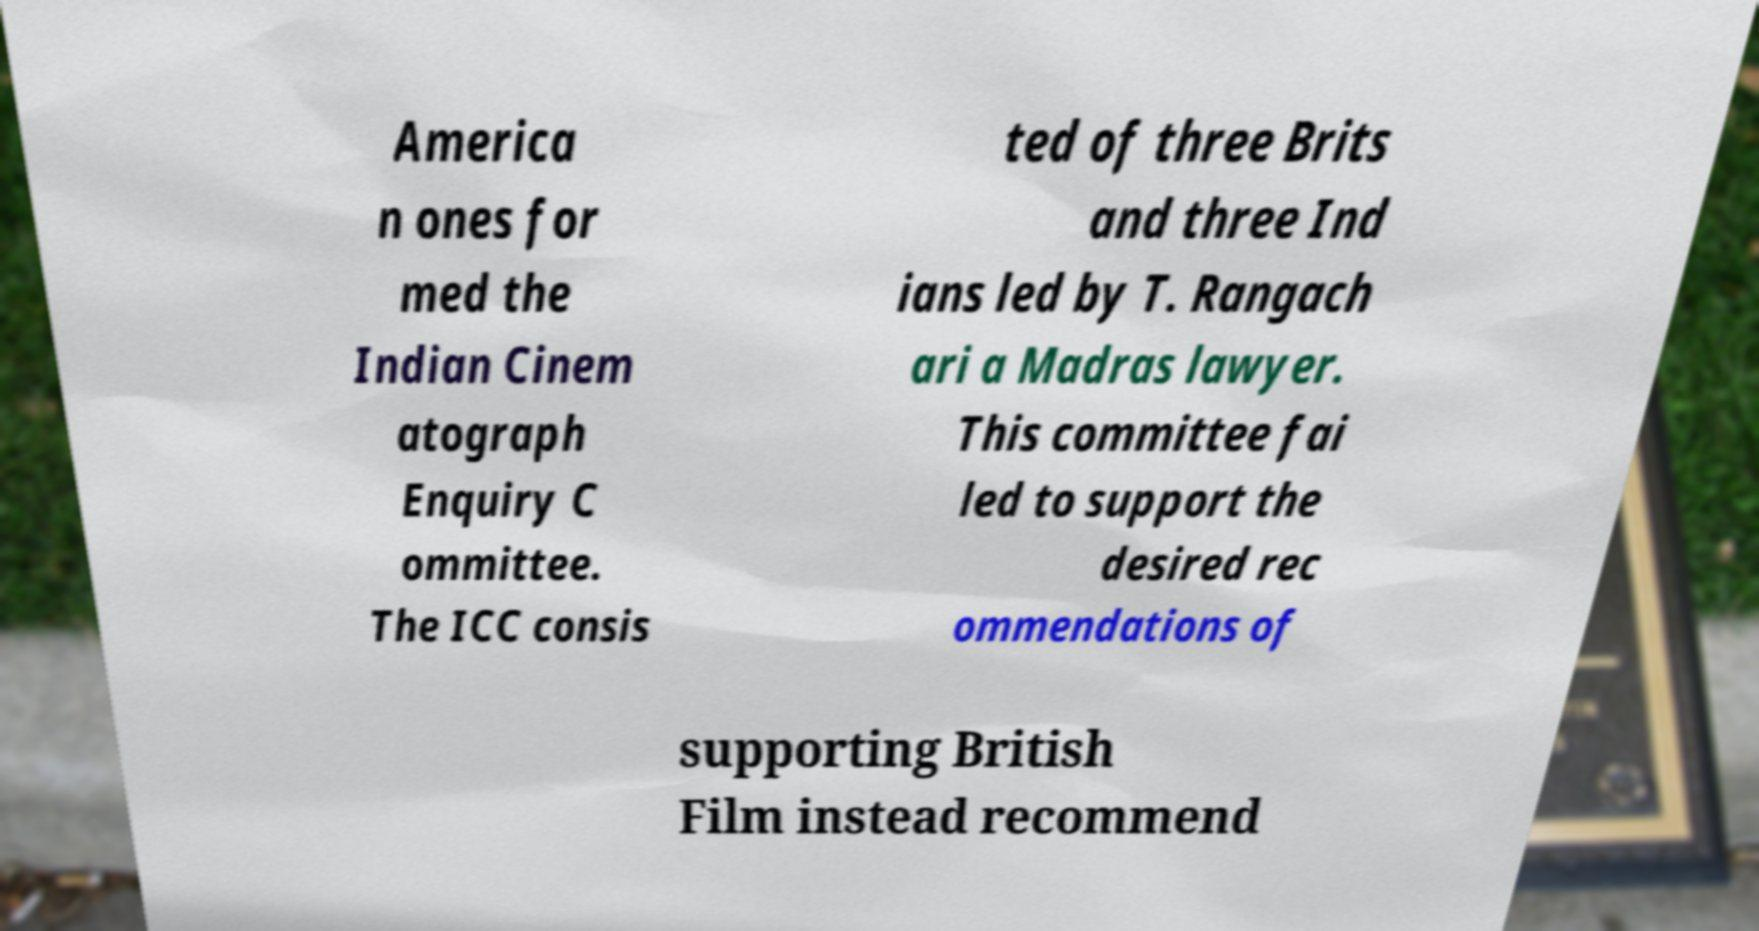Can you accurately transcribe the text from the provided image for me? America n ones for med the Indian Cinem atograph Enquiry C ommittee. The ICC consis ted of three Brits and three Ind ians led by T. Rangach ari a Madras lawyer. This committee fai led to support the desired rec ommendations of supporting British Film instead recommend 